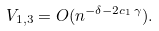<formula> <loc_0><loc_0><loc_500><loc_500>V _ { 1 , 3 } = O ( n ^ { - \delta - 2 c _ { 1 } \, \gamma } ) .</formula> 